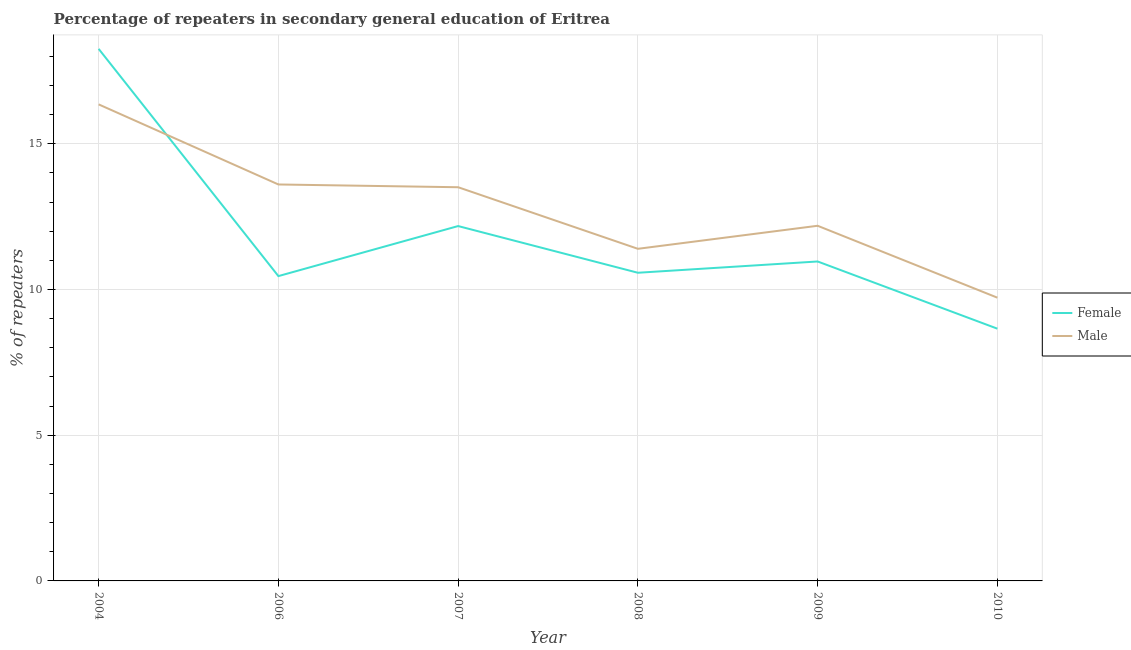Is the number of lines equal to the number of legend labels?
Provide a succinct answer. Yes. What is the percentage of female repeaters in 2008?
Provide a succinct answer. 10.58. Across all years, what is the maximum percentage of male repeaters?
Provide a short and direct response. 16.35. Across all years, what is the minimum percentage of male repeaters?
Ensure brevity in your answer.  9.72. In which year was the percentage of female repeaters minimum?
Your answer should be compact. 2010. What is the total percentage of female repeaters in the graph?
Provide a short and direct response. 71.1. What is the difference between the percentage of male repeaters in 2004 and that in 2010?
Offer a terse response. 6.63. What is the difference between the percentage of female repeaters in 2008 and the percentage of male repeaters in 2007?
Your response must be concise. -2.94. What is the average percentage of female repeaters per year?
Provide a short and direct response. 11.85. In the year 2008, what is the difference between the percentage of female repeaters and percentage of male repeaters?
Offer a very short reply. -0.82. In how many years, is the percentage of female repeaters greater than 14 %?
Your answer should be very brief. 1. What is the ratio of the percentage of female repeaters in 2008 to that in 2010?
Your answer should be very brief. 1.22. Is the difference between the percentage of female repeaters in 2004 and 2006 greater than the difference between the percentage of male repeaters in 2004 and 2006?
Offer a very short reply. Yes. What is the difference between the highest and the second highest percentage of male repeaters?
Keep it short and to the point. 2.75. What is the difference between the highest and the lowest percentage of male repeaters?
Offer a very short reply. 6.63. In how many years, is the percentage of male repeaters greater than the average percentage of male repeaters taken over all years?
Ensure brevity in your answer.  3. Is the sum of the percentage of female repeaters in 2004 and 2007 greater than the maximum percentage of male repeaters across all years?
Your response must be concise. Yes. Is the percentage of male repeaters strictly greater than the percentage of female repeaters over the years?
Ensure brevity in your answer.  No. Is the percentage of male repeaters strictly less than the percentage of female repeaters over the years?
Provide a succinct answer. No. How many lines are there?
Provide a succinct answer. 2. Are the values on the major ticks of Y-axis written in scientific E-notation?
Provide a succinct answer. No. Does the graph contain grids?
Provide a succinct answer. Yes. Where does the legend appear in the graph?
Ensure brevity in your answer.  Center right. How many legend labels are there?
Your answer should be compact. 2. What is the title of the graph?
Provide a succinct answer. Percentage of repeaters in secondary general education of Eritrea. What is the label or title of the X-axis?
Keep it short and to the point. Year. What is the label or title of the Y-axis?
Provide a short and direct response. % of repeaters. What is the % of repeaters of Female in 2004?
Make the answer very short. 18.26. What is the % of repeaters in Male in 2004?
Your answer should be very brief. 16.35. What is the % of repeaters in Female in 2006?
Offer a very short reply. 10.46. What is the % of repeaters of Male in 2006?
Your answer should be compact. 13.61. What is the % of repeaters of Female in 2007?
Provide a succinct answer. 12.18. What is the % of repeaters in Male in 2007?
Your response must be concise. 13.51. What is the % of repeaters in Female in 2008?
Your answer should be very brief. 10.58. What is the % of repeaters of Male in 2008?
Your answer should be compact. 11.4. What is the % of repeaters of Female in 2009?
Offer a terse response. 10.96. What is the % of repeaters in Male in 2009?
Offer a very short reply. 12.19. What is the % of repeaters of Female in 2010?
Your response must be concise. 8.66. What is the % of repeaters in Male in 2010?
Offer a very short reply. 9.72. Across all years, what is the maximum % of repeaters in Female?
Ensure brevity in your answer.  18.26. Across all years, what is the maximum % of repeaters in Male?
Offer a terse response. 16.35. Across all years, what is the minimum % of repeaters in Female?
Offer a terse response. 8.66. Across all years, what is the minimum % of repeaters of Male?
Your response must be concise. 9.72. What is the total % of repeaters in Female in the graph?
Offer a terse response. 71.1. What is the total % of repeaters of Male in the graph?
Provide a succinct answer. 76.78. What is the difference between the % of repeaters of Female in 2004 and that in 2006?
Ensure brevity in your answer.  7.8. What is the difference between the % of repeaters in Male in 2004 and that in 2006?
Your answer should be compact. 2.75. What is the difference between the % of repeaters in Female in 2004 and that in 2007?
Offer a terse response. 6.08. What is the difference between the % of repeaters in Male in 2004 and that in 2007?
Your answer should be very brief. 2.84. What is the difference between the % of repeaters of Female in 2004 and that in 2008?
Make the answer very short. 7.68. What is the difference between the % of repeaters in Male in 2004 and that in 2008?
Your answer should be compact. 4.96. What is the difference between the % of repeaters in Female in 2004 and that in 2009?
Your response must be concise. 7.3. What is the difference between the % of repeaters of Male in 2004 and that in 2009?
Provide a succinct answer. 4.17. What is the difference between the % of repeaters in Female in 2004 and that in 2010?
Provide a succinct answer. 9.6. What is the difference between the % of repeaters of Male in 2004 and that in 2010?
Give a very brief answer. 6.63. What is the difference between the % of repeaters of Female in 2006 and that in 2007?
Make the answer very short. -1.72. What is the difference between the % of repeaters in Male in 2006 and that in 2007?
Make the answer very short. 0.09. What is the difference between the % of repeaters in Female in 2006 and that in 2008?
Your answer should be very brief. -0.11. What is the difference between the % of repeaters of Male in 2006 and that in 2008?
Your answer should be very brief. 2.21. What is the difference between the % of repeaters of Female in 2006 and that in 2009?
Your response must be concise. -0.5. What is the difference between the % of repeaters of Male in 2006 and that in 2009?
Ensure brevity in your answer.  1.42. What is the difference between the % of repeaters in Female in 2006 and that in 2010?
Provide a succinct answer. 1.8. What is the difference between the % of repeaters in Male in 2006 and that in 2010?
Keep it short and to the point. 3.88. What is the difference between the % of repeaters in Female in 2007 and that in 2008?
Offer a terse response. 1.6. What is the difference between the % of repeaters in Male in 2007 and that in 2008?
Your answer should be very brief. 2.11. What is the difference between the % of repeaters of Female in 2007 and that in 2009?
Provide a short and direct response. 1.22. What is the difference between the % of repeaters in Male in 2007 and that in 2009?
Keep it short and to the point. 1.32. What is the difference between the % of repeaters of Female in 2007 and that in 2010?
Ensure brevity in your answer.  3.52. What is the difference between the % of repeaters of Male in 2007 and that in 2010?
Provide a short and direct response. 3.79. What is the difference between the % of repeaters in Female in 2008 and that in 2009?
Your response must be concise. -0.39. What is the difference between the % of repeaters of Male in 2008 and that in 2009?
Offer a very short reply. -0.79. What is the difference between the % of repeaters of Female in 2008 and that in 2010?
Provide a succinct answer. 1.92. What is the difference between the % of repeaters of Male in 2008 and that in 2010?
Offer a terse response. 1.68. What is the difference between the % of repeaters of Female in 2009 and that in 2010?
Keep it short and to the point. 2.31. What is the difference between the % of repeaters in Male in 2009 and that in 2010?
Offer a terse response. 2.47. What is the difference between the % of repeaters in Female in 2004 and the % of repeaters in Male in 2006?
Offer a terse response. 4.65. What is the difference between the % of repeaters of Female in 2004 and the % of repeaters of Male in 2007?
Offer a terse response. 4.75. What is the difference between the % of repeaters of Female in 2004 and the % of repeaters of Male in 2008?
Give a very brief answer. 6.86. What is the difference between the % of repeaters in Female in 2004 and the % of repeaters in Male in 2009?
Offer a terse response. 6.07. What is the difference between the % of repeaters in Female in 2004 and the % of repeaters in Male in 2010?
Offer a very short reply. 8.54. What is the difference between the % of repeaters of Female in 2006 and the % of repeaters of Male in 2007?
Your response must be concise. -3.05. What is the difference between the % of repeaters of Female in 2006 and the % of repeaters of Male in 2008?
Offer a terse response. -0.94. What is the difference between the % of repeaters in Female in 2006 and the % of repeaters in Male in 2009?
Your answer should be compact. -1.73. What is the difference between the % of repeaters of Female in 2006 and the % of repeaters of Male in 2010?
Ensure brevity in your answer.  0.74. What is the difference between the % of repeaters of Female in 2007 and the % of repeaters of Male in 2008?
Make the answer very short. 0.78. What is the difference between the % of repeaters of Female in 2007 and the % of repeaters of Male in 2009?
Offer a terse response. -0.01. What is the difference between the % of repeaters of Female in 2007 and the % of repeaters of Male in 2010?
Your response must be concise. 2.46. What is the difference between the % of repeaters of Female in 2008 and the % of repeaters of Male in 2009?
Keep it short and to the point. -1.61. What is the difference between the % of repeaters in Female in 2008 and the % of repeaters in Male in 2010?
Keep it short and to the point. 0.85. What is the difference between the % of repeaters of Female in 2009 and the % of repeaters of Male in 2010?
Offer a terse response. 1.24. What is the average % of repeaters of Female per year?
Offer a very short reply. 11.85. What is the average % of repeaters in Male per year?
Provide a succinct answer. 12.8. In the year 2004, what is the difference between the % of repeaters of Female and % of repeaters of Male?
Ensure brevity in your answer.  1.91. In the year 2006, what is the difference between the % of repeaters in Female and % of repeaters in Male?
Offer a very short reply. -3.15. In the year 2007, what is the difference between the % of repeaters in Female and % of repeaters in Male?
Provide a succinct answer. -1.33. In the year 2008, what is the difference between the % of repeaters of Female and % of repeaters of Male?
Your answer should be very brief. -0.82. In the year 2009, what is the difference between the % of repeaters in Female and % of repeaters in Male?
Ensure brevity in your answer.  -1.23. In the year 2010, what is the difference between the % of repeaters in Female and % of repeaters in Male?
Offer a very short reply. -1.06. What is the ratio of the % of repeaters of Female in 2004 to that in 2006?
Your answer should be compact. 1.75. What is the ratio of the % of repeaters of Male in 2004 to that in 2006?
Give a very brief answer. 1.2. What is the ratio of the % of repeaters of Female in 2004 to that in 2007?
Give a very brief answer. 1.5. What is the ratio of the % of repeaters of Male in 2004 to that in 2007?
Provide a short and direct response. 1.21. What is the ratio of the % of repeaters of Female in 2004 to that in 2008?
Your answer should be very brief. 1.73. What is the ratio of the % of repeaters of Male in 2004 to that in 2008?
Your answer should be compact. 1.43. What is the ratio of the % of repeaters of Female in 2004 to that in 2009?
Make the answer very short. 1.67. What is the ratio of the % of repeaters in Male in 2004 to that in 2009?
Make the answer very short. 1.34. What is the ratio of the % of repeaters of Female in 2004 to that in 2010?
Your answer should be compact. 2.11. What is the ratio of the % of repeaters of Male in 2004 to that in 2010?
Offer a very short reply. 1.68. What is the ratio of the % of repeaters of Female in 2006 to that in 2007?
Offer a terse response. 0.86. What is the ratio of the % of repeaters of Male in 2006 to that in 2007?
Offer a terse response. 1.01. What is the ratio of the % of repeaters in Female in 2006 to that in 2008?
Provide a short and direct response. 0.99. What is the ratio of the % of repeaters in Male in 2006 to that in 2008?
Provide a short and direct response. 1.19. What is the ratio of the % of repeaters in Female in 2006 to that in 2009?
Keep it short and to the point. 0.95. What is the ratio of the % of repeaters of Male in 2006 to that in 2009?
Offer a terse response. 1.12. What is the ratio of the % of repeaters in Female in 2006 to that in 2010?
Provide a succinct answer. 1.21. What is the ratio of the % of repeaters of Male in 2006 to that in 2010?
Offer a terse response. 1.4. What is the ratio of the % of repeaters in Female in 2007 to that in 2008?
Make the answer very short. 1.15. What is the ratio of the % of repeaters of Male in 2007 to that in 2008?
Offer a terse response. 1.19. What is the ratio of the % of repeaters of Female in 2007 to that in 2009?
Give a very brief answer. 1.11. What is the ratio of the % of repeaters in Male in 2007 to that in 2009?
Your answer should be very brief. 1.11. What is the ratio of the % of repeaters in Female in 2007 to that in 2010?
Offer a terse response. 1.41. What is the ratio of the % of repeaters of Male in 2007 to that in 2010?
Ensure brevity in your answer.  1.39. What is the ratio of the % of repeaters of Female in 2008 to that in 2009?
Offer a terse response. 0.96. What is the ratio of the % of repeaters in Male in 2008 to that in 2009?
Your answer should be very brief. 0.94. What is the ratio of the % of repeaters of Female in 2008 to that in 2010?
Make the answer very short. 1.22. What is the ratio of the % of repeaters of Male in 2008 to that in 2010?
Offer a very short reply. 1.17. What is the ratio of the % of repeaters in Female in 2009 to that in 2010?
Ensure brevity in your answer.  1.27. What is the ratio of the % of repeaters of Male in 2009 to that in 2010?
Make the answer very short. 1.25. What is the difference between the highest and the second highest % of repeaters of Female?
Your answer should be very brief. 6.08. What is the difference between the highest and the second highest % of repeaters of Male?
Your answer should be compact. 2.75. What is the difference between the highest and the lowest % of repeaters in Female?
Ensure brevity in your answer.  9.6. What is the difference between the highest and the lowest % of repeaters in Male?
Your response must be concise. 6.63. 